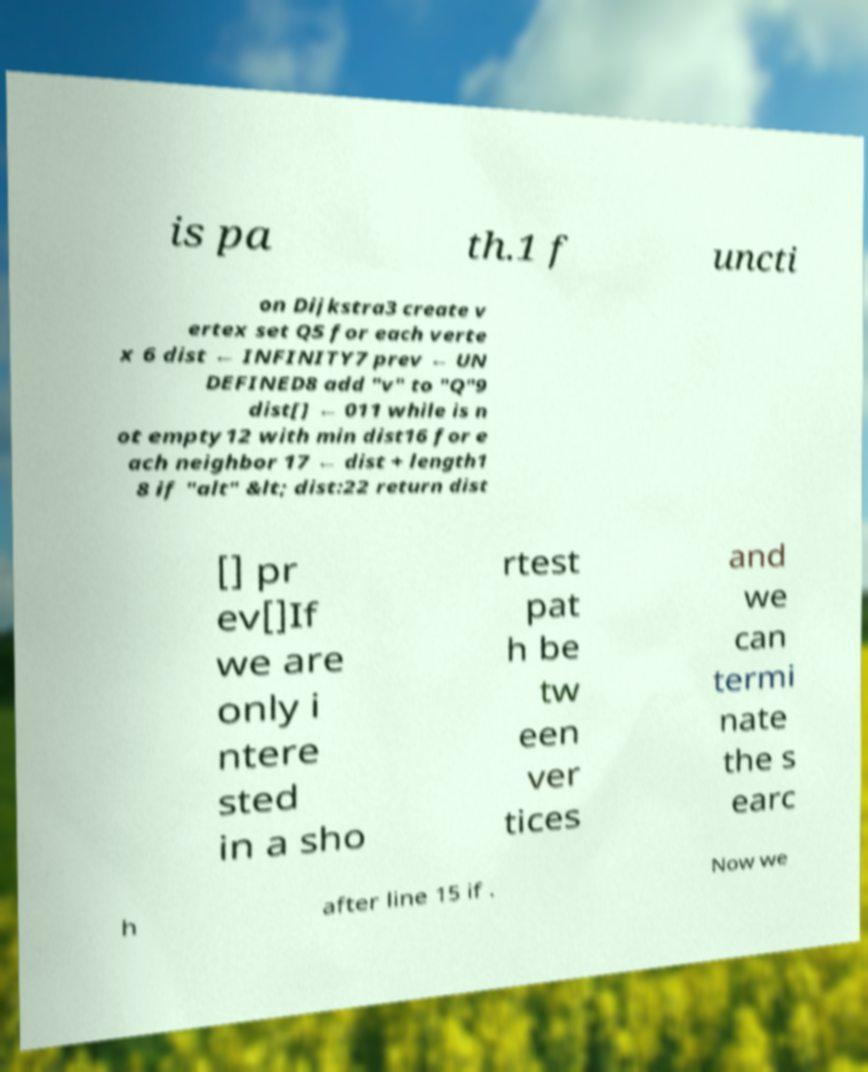There's text embedded in this image that I need extracted. Can you transcribe it verbatim? is pa th.1 f uncti on Dijkstra3 create v ertex set Q5 for each verte x 6 dist ← INFINITY7 prev ← UN DEFINED8 add "v" to "Q"9 dist[] ← 011 while is n ot empty12 with min dist16 for e ach neighbor 17 ← dist + length1 8 if "alt" &lt; dist:22 return dist [] pr ev[]If we are only i ntere sted in a sho rtest pat h be tw een ver tices and we can termi nate the s earc h after line 15 if . Now we 